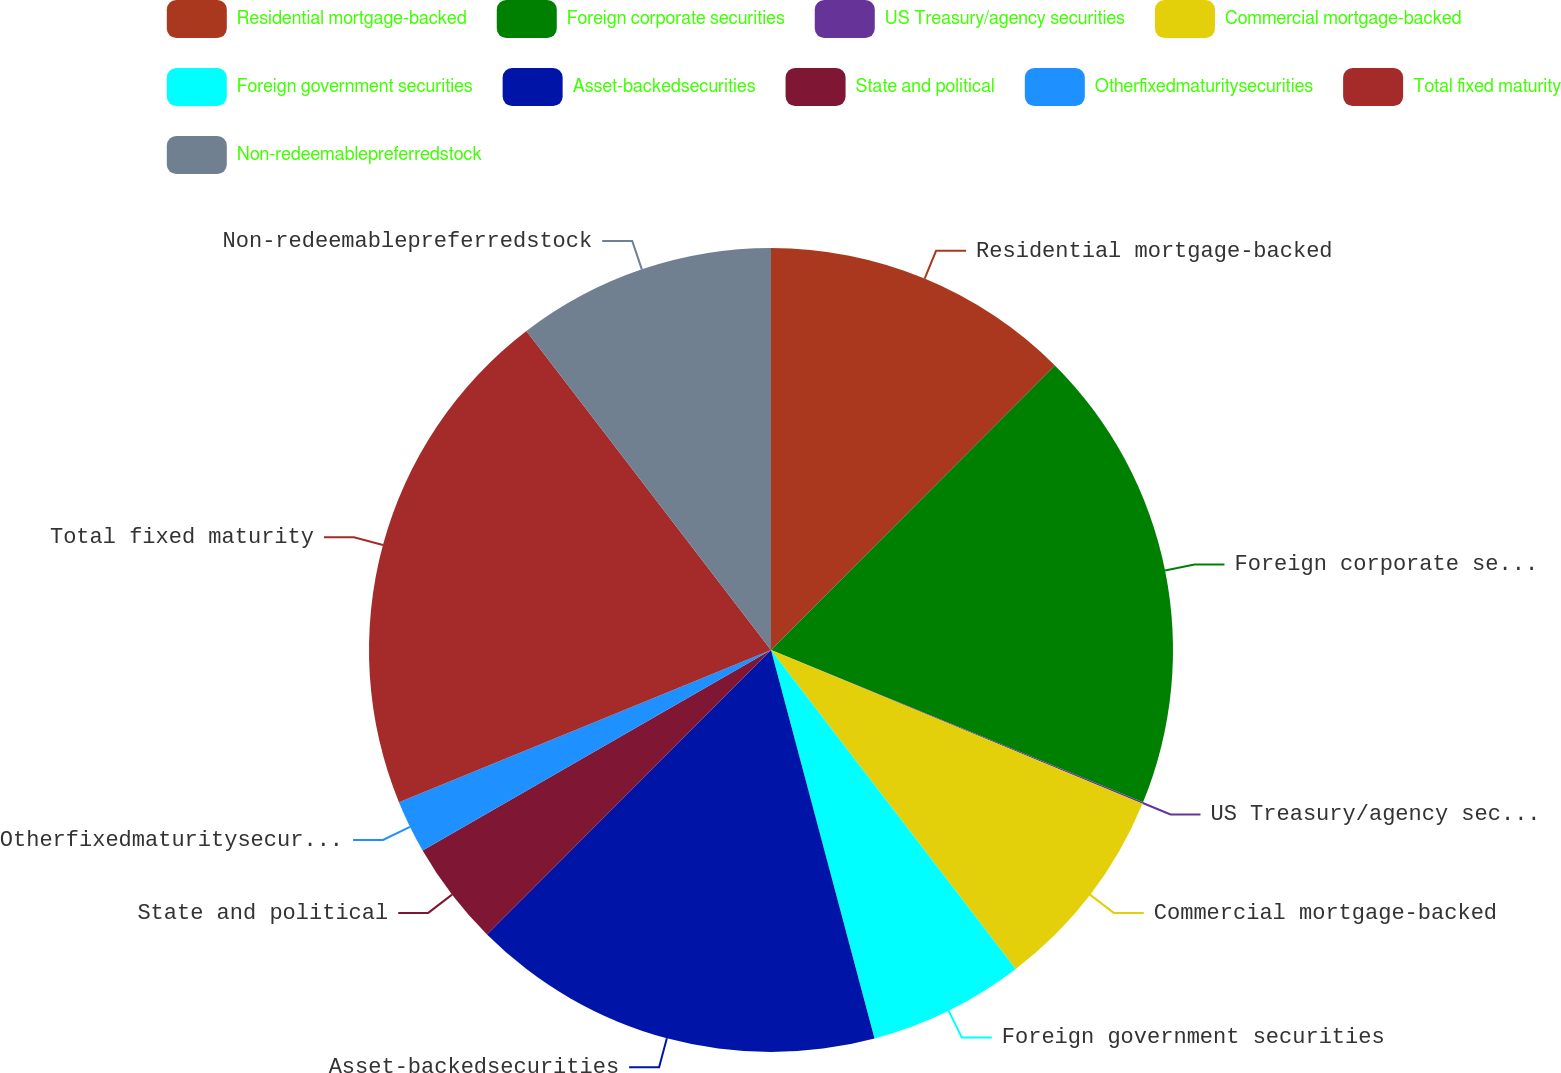Convert chart to OTSL. <chart><loc_0><loc_0><loc_500><loc_500><pie_chart><fcel>Residential mortgage-backed<fcel>Foreign corporate securities<fcel>US Treasury/agency securities<fcel>Commercial mortgage-backed<fcel>Foreign government securities<fcel>Asset-backedsecurities<fcel>State and political<fcel>Otherfixedmaturitysecurities<fcel>Total fixed maturity<fcel>Non-redeemablepreferredstock<nl><fcel>12.48%<fcel>18.7%<fcel>0.06%<fcel>8.34%<fcel>6.27%<fcel>16.63%<fcel>4.2%<fcel>2.13%<fcel>20.77%<fcel>10.41%<nl></chart> 